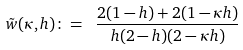<formula> <loc_0><loc_0><loc_500><loc_500>\tilde { w } ( \kappa , h ) \colon = \ \frac { 2 ( 1 - h ) + 2 ( 1 - \kappa h ) } { h ( 2 - h ) ( 2 - \kappa h ) }</formula> 